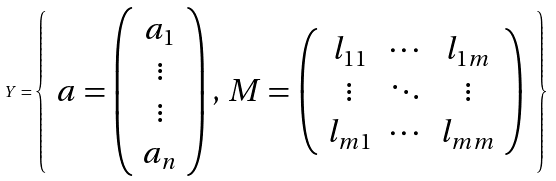<formula> <loc_0><loc_0><loc_500><loc_500>Y = \left \{ \begin{array} { c } a = \left ( \begin{array} { c } a _ { 1 } \\ \vdots \\ \vdots \\ a _ { n } \end{array} \right ) , \, M = \left ( \begin{array} { c c c } l _ { 1 1 } & \cdots & l _ { 1 m } \\ \vdots & \ddots & \vdots \\ l _ { m 1 } & \cdots & l _ { m m } \end{array} \right ) \end{array} \right \}</formula> 